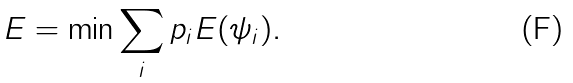Convert formula to latex. <formula><loc_0><loc_0><loc_500><loc_500>E = \min \sum _ { i } p _ { i } E ( \psi _ { i } ) .</formula> 